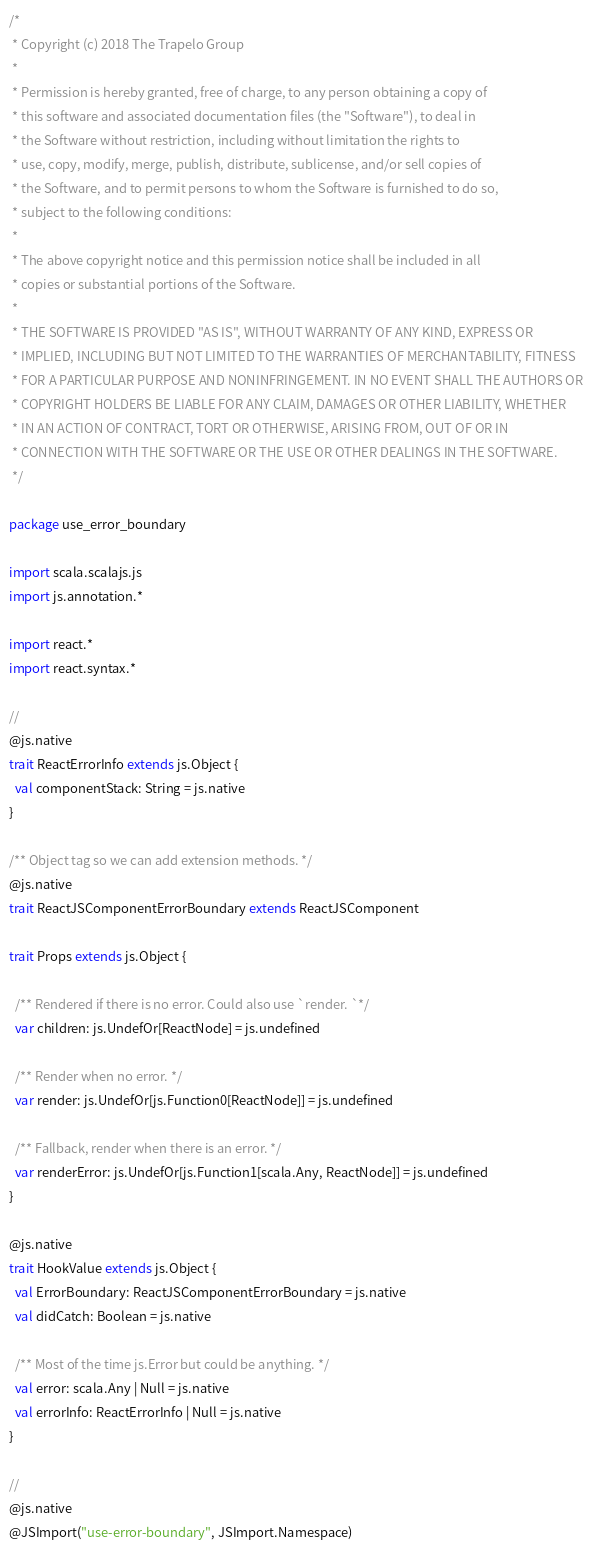<code> <loc_0><loc_0><loc_500><loc_500><_Scala_>/*
 * Copyright (c) 2018 The Trapelo Group
 *
 * Permission is hereby granted, free of charge, to any person obtaining a copy of
 * this software and associated documentation files (the "Software"), to deal in
 * the Software without restriction, including without limitation the rights to
 * use, copy, modify, merge, publish, distribute, sublicense, and/or sell copies of
 * the Software, and to permit persons to whom the Software is furnished to do so,
 * subject to the following conditions:
 *
 * The above copyright notice and this permission notice shall be included in all
 * copies or substantial portions of the Software.
 *
 * THE SOFTWARE IS PROVIDED "AS IS", WITHOUT WARRANTY OF ANY KIND, EXPRESS OR
 * IMPLIED, INCLUDING BUT NOT LIMITED TO THE WARRANTIES OF MERCHANTABILITY, FITNESS
 * FOR A PARTICULAR PURPOSE AND NONINFRINGEMENT. IN NO EVENT SHALL THE AUTHORS OR
 * COPYRIGHT HOLDERS BE LIABLE FOR ANY CLAIM, DAMAGES OR OTHER LIABILITY, WHETHER
 * IN AN ACTION OF CONTRACT, TORT OR OTHERWISE, ARISING FROM, OUT OF OR IN
 * CONNECTION WITH THE SOFTWARE OR THE USE OR OTHER DEALINGS IN THE SOFTWARE.
 */

package use_error_boundary

import scala.scalajs.js
import js.annotation.*

import react.*
import react.syntax.*

//
@js.native
trait ReactErrorInfo extends js.Object {
  val componentStack: String = js.native
}

/** Object tag so we can add extension methods. */
@js.native
trait ReactJSComponentErrorBoundary extends ReactJSComponent

trait Props extends js.Object {

  /** Rendered if there is no error. Could also use `render. `*/
  var children: js.UndefOr[ReactNode] = js.undefined

  /** Render when no error. */
  var render: js.UndefOr[js.Function0[ReactNode]] = js.undefined

  /** Fallback, render when there is an error. */
  var renderError: js.UndefOr[js.Function1[scala.Any, ReactNode]] = js.undefined
}

@js.native
trait HookValue extends js.Object {
  val ErrorBoundary: ReactJSComponentErrorBoundary = js.native
  val didCatch: Boolean = js.native

  /** Most of the time js.Error but could be anything. */
  val error: scala.Any | Null = js.native
  val errorInfo: ReactErrorInfo | Null = js.native
}

//
@js.native
@JSImport("use-error-boundary", JSImport.Namespace)</code> 